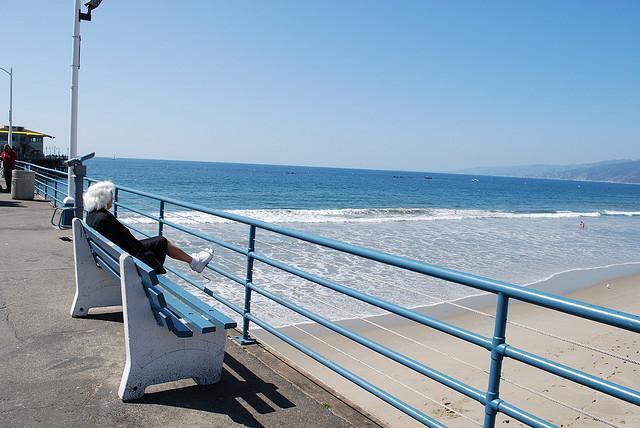How many benches are there?
Give a very brief answer. 1. How many people have their head covered?
Give a very brief answer. 0. 